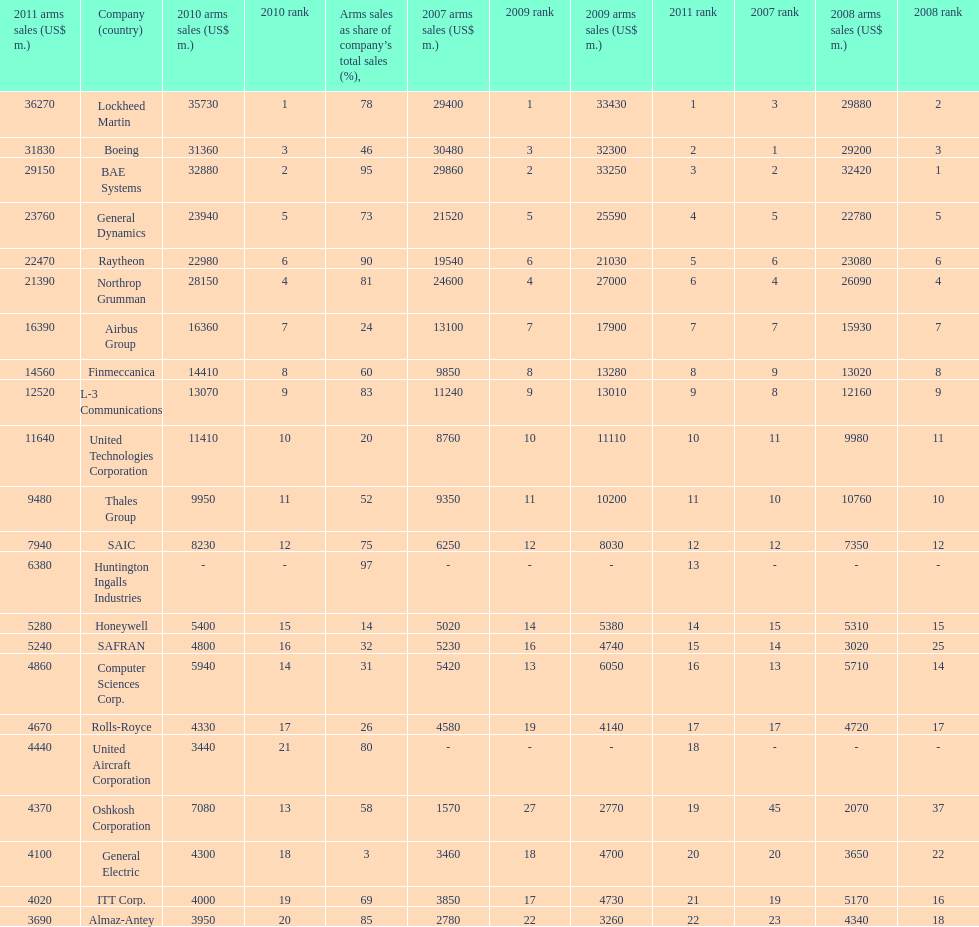Which is the only company to have under 10% arms sales as share of company's total sales? General Electric. 